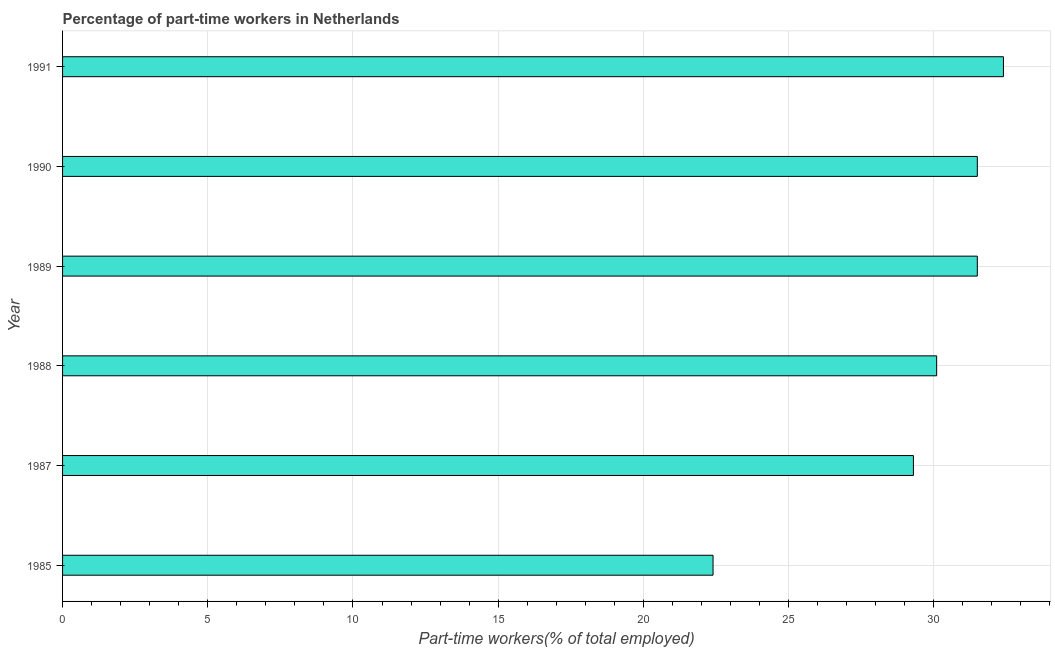What is the title of the graph?
Your answer should be compact. Percentage of part-time workers in Netherlands. What is the label or title of the X-axis?
Give a very brief answer. Part-time workers(% of total employed). What is the percentage of part-time workers in 1987?
Give a very brief answer. 29.3. Across all years, what is the maximum percentage of part-time workers?
Provide a short and direct response. 32.4. Across all years, what is the minimum percentage of part-time workers?
Provide a succinct answer. 22.4. In which year was the percentage of part-time workers maximum?
Ensure brevity in your answer.  1991. In which year was the percentage of part-time workers minimum?
Your answer should be very brief. 1985. What is the sum of the percentage of part-time workers?
Give a very brief answer. 177.2. What is the average percentage of part-time workers per year?
Offer a very short reply. 29.53. What is the median percentage of part-time workers?
Offer a very short reply. 30.8. Do a majority of the years between 1990 and 1987 (inclusive) have percentage of part-time workers greater than 2 %?
Provide a succinct answer. Yes. What is the ratio of the percentage of part-time workers in 1987 to that in 1990?
Ensure brevity in your answer.  0.93. Is the difference between the percentage of part-time workers in 1985 and 1988 greater than the difference between any two years?
Provide a succinct answer. No. What is the difference between the highest and the second highest percentage of part-time workers?
Your answer should be very brief. 0.9. What is the difference between the highest and the lowest percentage of part-time workers?
Your answer should be compact. 10. In how many years, is the percentage of part-time workers greater than the average percentage of part-time workers taken over all years?
Your answer should be compact. 4. Are all the bars in the graph horizontal?
Provide a succinct answer. Yes. How many years are there in the graph?
Your answer should be compact. 6. Are the values on the major ticks of X-axis written in scientific E-notation?
Give a very brief answer. No. What is the Part-time workers(% of total employed) in 1985?
Offer a terse response. 22.4. What is the Part-time workers(% of total employed) of 1987?
Give a very brief answer. 29.3. What is the Part-time workers(% of total employed) of 1988?
Your answer should be compact. 30.1. What is the Part-time workers(% of total employed) in 1989?
Provide a short and direct response. 31.5. What is the Part-time workers(% of total employed) in 1990?
Ensure brevity in your answer.  31.5. What is the Part-time workers(% of total employed) of 1991?
Your answer should be compact. 32.4. What is the difference between the Part-time workers(% of total employed) in 1985 and 1987?
Your answer should be compact. -6.9. What is the difference between the Part-time workers(% of total employed) in 1985 and 1988?
Make the answer very short. -7.7. What is the difference between the Part-time workers(% of total employed) in 1985 and 1989?
Offer a very short reply. -9.1. What is the difference between the Part-time workers(% of total employed) in 1985 and 1990?
Keep it short and to the point. -9.1. What is the difference between the Part-time workers(% of total employed) in 1985 and 1991?
Offer a terse response. -10. What is the difference between the Part-time workers(% of total employed) in 1987 and 1991?
Keep it short and to the point. -3.1. What is the difference between the Part-time workers(% of total employed) in 1988 and 1989?
Your response must be concise. -1.4. What is the difference between the Part-time workers(% of total employed) in 1988 and 1990?
Offer a terse response. -1.4. What is the difference between the Part-time workers(% of total employed) in 1988 and 1991?
Offer a terse response. -2.3. What is the difference between the Part-time workers(% of total employed) in 1989 and 1990?
Provide a short and direct response. 0. What is the difference between the Part-time workers(% of total employed) in 1989 and 1991?
Your response must be concise. -0.9. What is the difference between the Part-time workers(% of total employed) in 1990 and 1991?
Offer a very short reply. -0.9. What is the ratio of the Part-time workers(% of total employed) in 1985 to that in 1987?
Your answer should be very brief. 0.77. What is the ratio of the Part-time workers(% of total employed) in 1985 to that in 1988?
Provide a short and direct response. 0.74. What is the ratio of the Part-time workers(% of total employed) in 1985 to that in 1989?
Provide a succinct answer. 0.71. What is the ratio of the Part-time workers(% of total employed) in 1985 to that in 1990?
Give a very brief answer. 0.71. What is the ratio of the Part-time workers(% of total employed) in 1985 to that in 1991?
Provide a succinct answer. 0.69. What is the ratio of the Part-time workers(% of total employed) in 1987 to that in 1991?
Make the answer very short. 0.9. What is the ratio of the Part-time workers(% of total employed) in 1988 to that in 1989?
Provide a short and direct response. 0.96. What is the ratio of the Part-time workers(% of total employed) in 1988 to that in 1990?
Your answer should be very brief. 0.96. What is the ratio of the Part-time workers(% of total employed) in 1988 to that in 1991?
Provide a short and direct response. 0.93. What is the ratio of the Part-time workers(% of total employed) in 1989 to that in 1990?
Ensure brevity in your answer.  1. What is the ratio of the Part-time workers(% of total employed) in 1990 to that in 1991?
Provide a short and direct response. 0.97. 